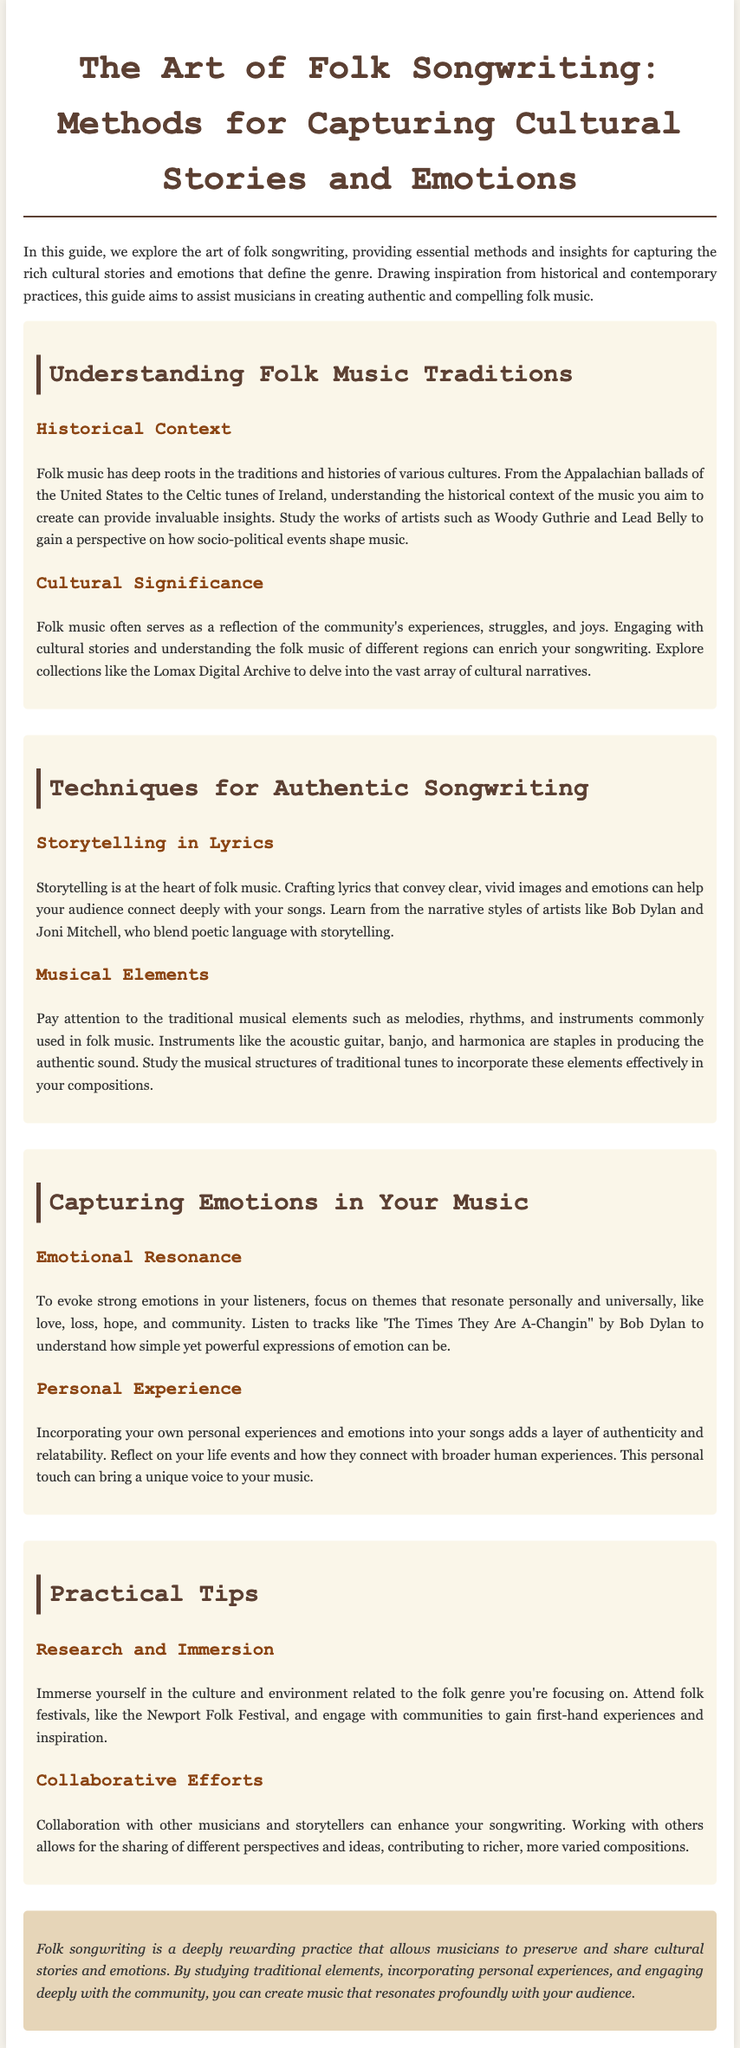What is the title of the guide? The title of the guide is prominently displayed at the beginning of the document, providing a clear indication of its focus.
Answer: The Art of Folk Songwriting: Methods for Capturing Cultural Stories and Emotions Who is mentioned as an artist related to storytelling in lyrics? The document discusses various artists known for their storytelling techniques in folk music, specifically naming them in the context of effective songwriting.
Answer: Bob Dylan What is a key instrument used in folk music? The guide highlights specific instruments significant to the folk genre, particularly noting a few staples that define its sound.
Answer: Acoustic guitar What theme is emphasized for evoking emotions in music? The document highlights a particular theme that resonates well with audiences, contributing to the emotional impact of folk music.
Answer: Love Which famous folk festival is suggested for immersion in culture? The guide recommends attending a specific festival to gain first-hand experiences and inspiration related to folk music traditions.
Answer: Newport Folk Festival What is the section that focuses on techniques for songwriting? The document is divided into sections, each shedding light on different aspects of the folk songwriting process, with specific sections addressing particular methods.
Answer: Techniques for Authentic Songwriting Who are two artists mentioned in relation to narrative styles? The guide refers to notable musicians as examples of effective narrative techniques in folk songwriting, identifying two well-known figures.
Answer: Bob Dylan and Joni Mitchell What resource is suggested for exploring cultural narratives? The guide points to a specific digital collection that can help songwriters delve into the rich array of cultural stories within folk music.
Answer: Lomax Digital Archive What is the overall goal of folk songwriting according to the conclusion? The conclusion summarizes the purpose of engaging in folk songwriting, emphasizing what musicians aim to achieve through their craft.
Answer: Preserve and share cultural stories and emotions 